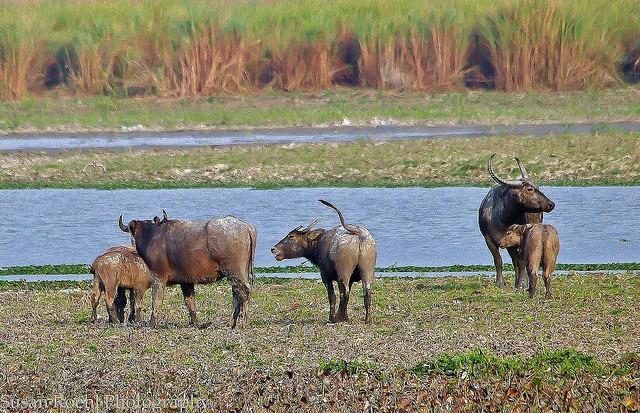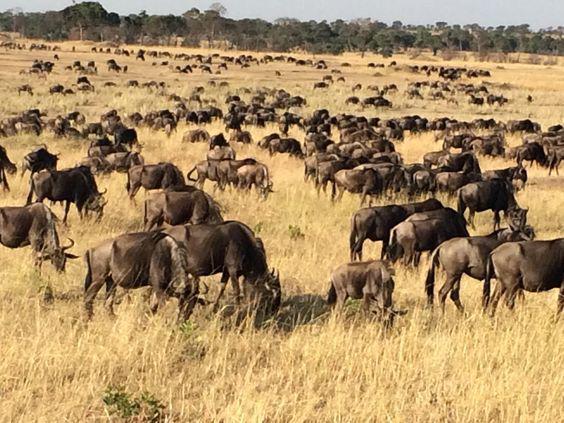The first image is the image on the left, the second image is the image on the right. Evaluate the accuracy of this statement regarding the images: "The sky is visible in the left image.". Is it true? Answer yes or no. No. The first image is the image on the left, the second image is the image on the right. Examine the images to the left and right. Is the description "In each image, at least one forward-facing water buffalo with raised head is prominent, and no image contains more than a dozen distinguishable buffalo." accurate? Answer yes or no. No. 